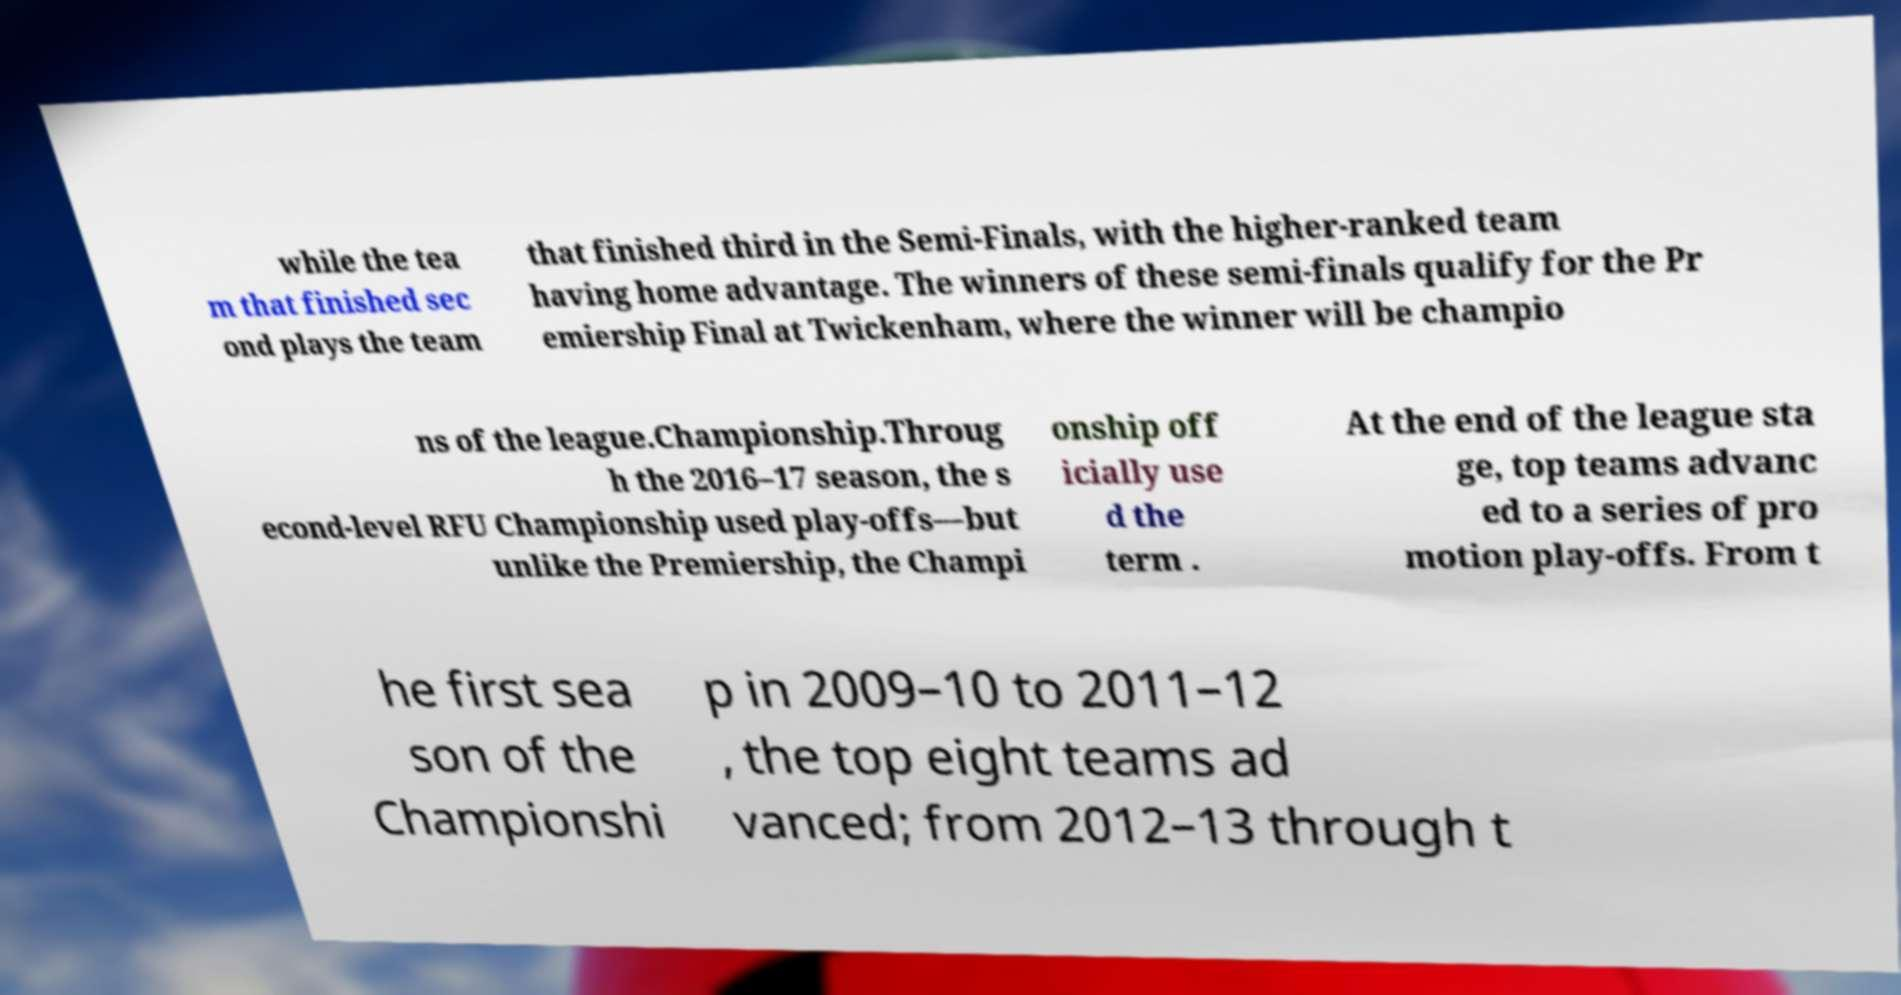Can you read and provide the text displayed in the image?This photo seems to have some interesting text. Can you extract and type it out for me? while the tea m that finished sec ond plays the team that finished third in the Semi-Finals, with the higher-ranked team having home advantage. The winners of these semi-finals qualify for the Pr emiership Final at Twickenham, where the winner will be champio ns of the league.Championship.Throug h the 2016–17 season, the s econd-level RFU Championship used play-offs—but unlike the Premiership, the Champi onship off icially use d the term . At the end of the league sta ge, top teams advanc ed to a series of pro motion play-offs. From t he first sea son of the Championshi p in 2009–10 to 2011–12 , the top eight teams ad vanced; from 2012–13 through t 